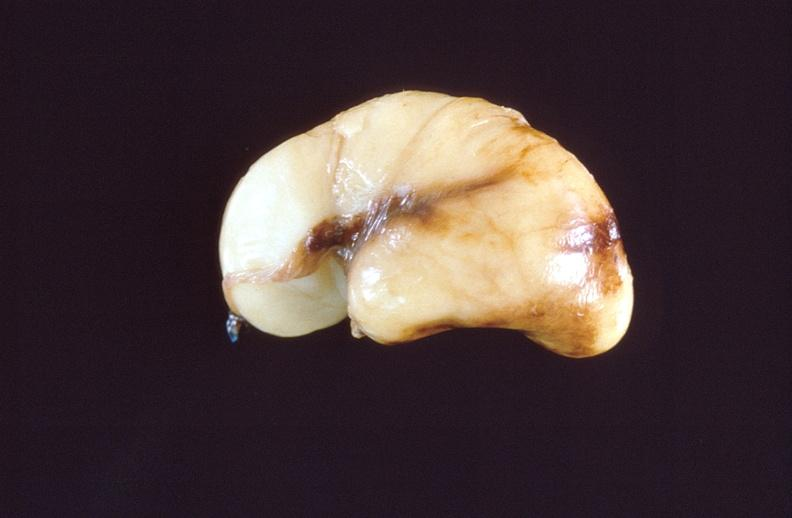does carcinoma metastatic lung show intraventricular hemorrhage, neonate brain?
Answer the question using a single word or phrase. No 